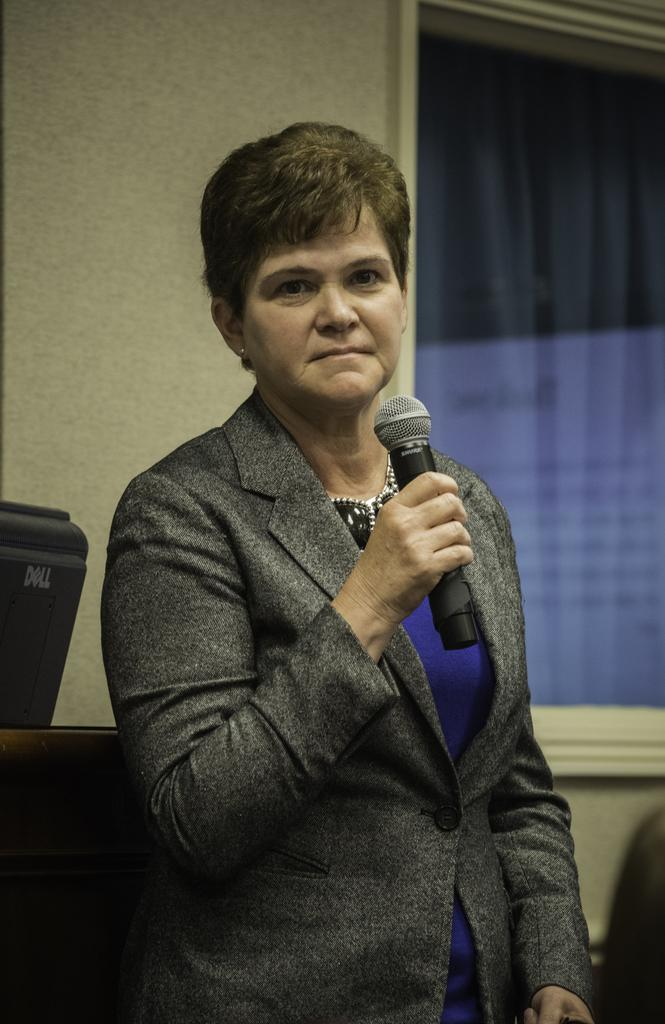What is the main subject of the image? There is a person in the image. What is the person doing in the image? The person is standing and holding a microphone in her hand. What can be seen behind the person? There is a wall behind the person. What architectural feature is present at the right end of the image? There is a glass window at the right end of the image. How many boats can be seen sailing in the background of the image? There are no boats visible in the image; it features a person standing with a microphone and a glass window at the right end. What type of twig is being used by the person to hold the microphone? The person is not using a twig to hold the microphone; she is holding it directly in her hand. 